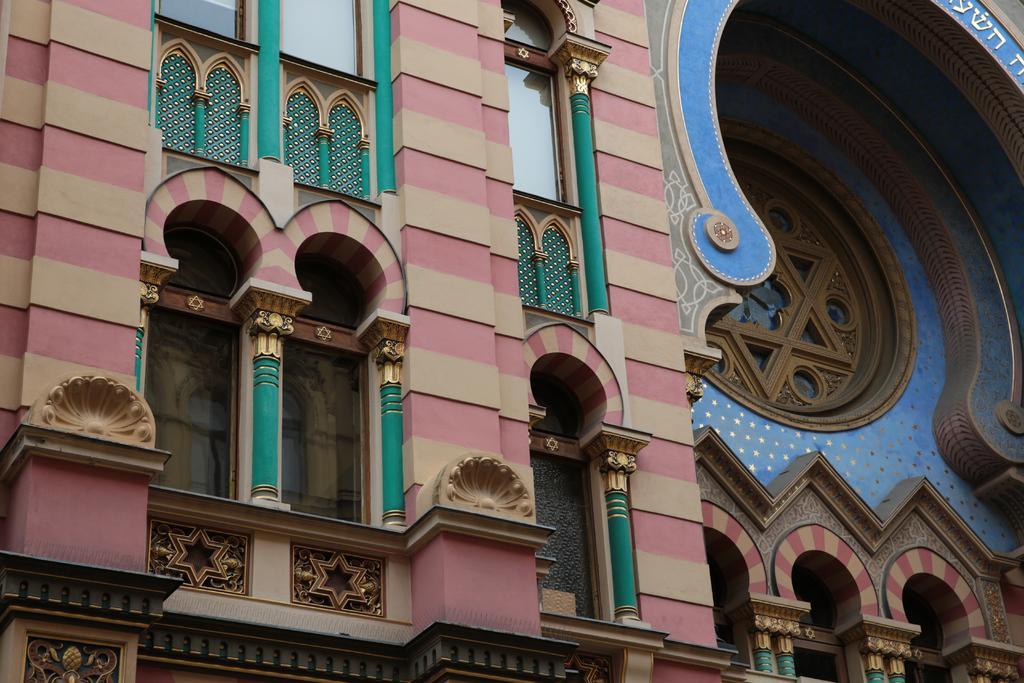Can you describe this image briefly? In this picture we can see building and glass windows. 